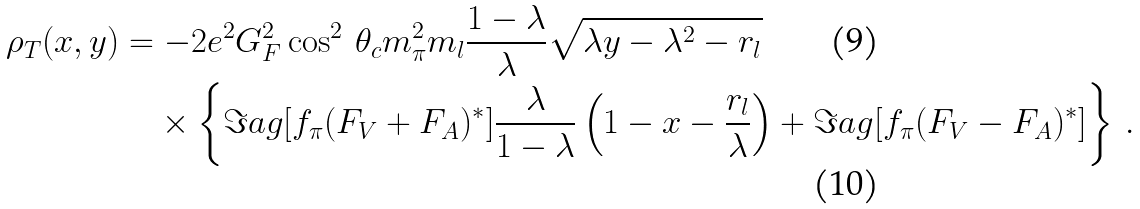<formula> <loc_0><loc_0><loc_500><loc_500>\rho _ { T } ( x , y ) & = - 2 e ^ { 2 } G ^ { 2 } _ { F } \cos ^ { 2 } \, \theta _ { c } m ^ { 2 } _ { \pi } m _ { l } \frac { 1 - \lambda } { \lambda } \sqrt { \lambda y - \lambda ^ { 2 } - r _ { l } } \\ & \quad \times \left \{ \Im a g [ f _ { \pi } ( F _ { V } + F _ { A } ) ^ { * } ] \frac { \lambda } { 1 - \lambda } \left ( 1 - x - \frac { r _ { l } } { \lambda } \right ) + \Im a g [ f _ { \pi } ( F _ { V } - F _ { A } ) ^ { * } ] \right \} \, .</formula> 